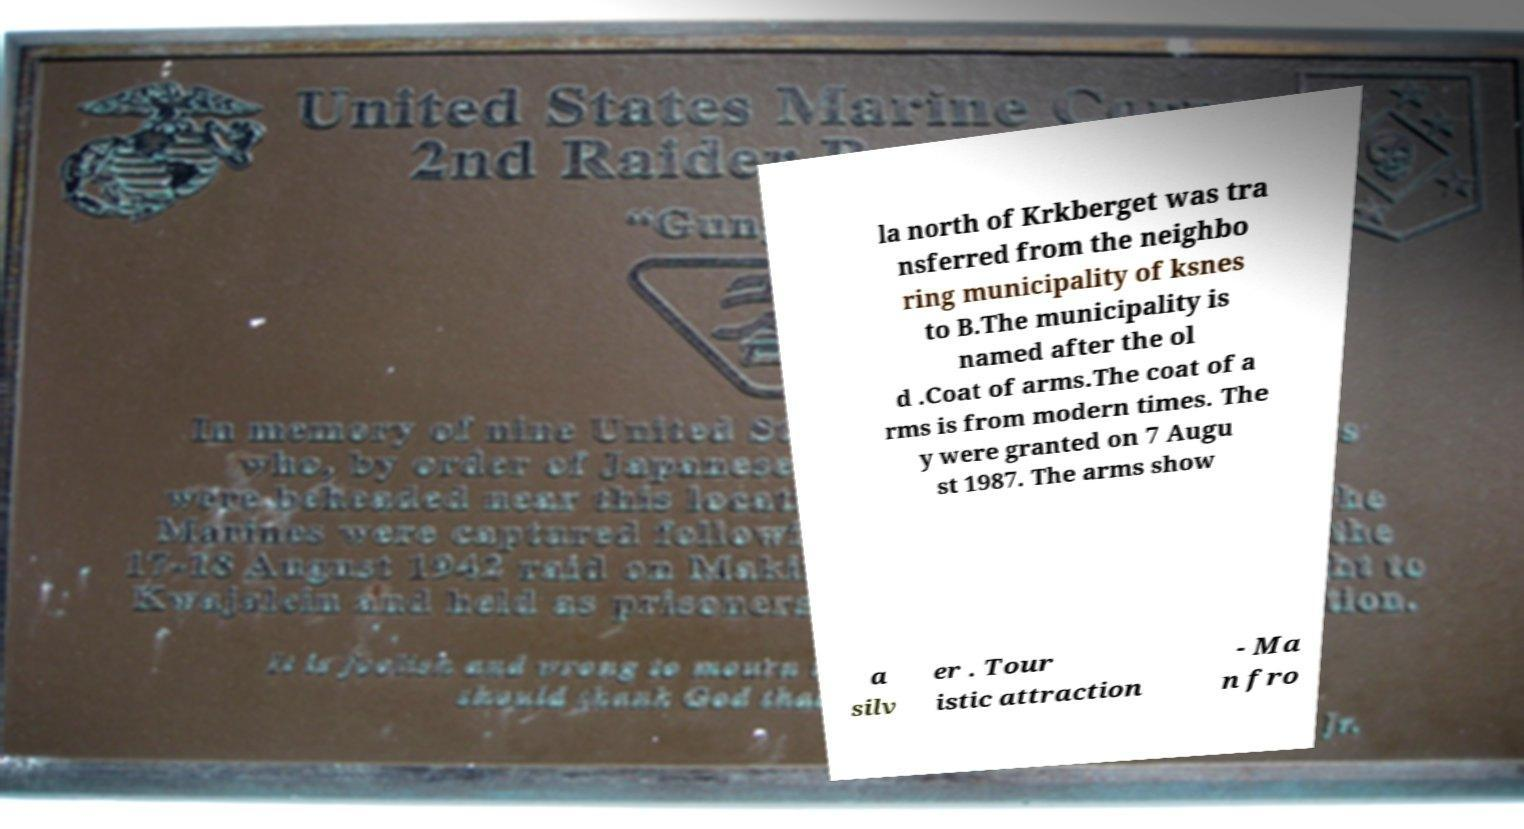For documentation purposes, I need the text within this image transcribed. Could you provide that? la north of Krkberget was tra nsferred from the neighbo ring municipality of ksnes to B.The municipality is named after the ol d .Coat of arms.The coat of a rms is from modern times. The y were granted on 7 Augu st 1987. The arms show a silv er . Tour istic attraction - Ma n fro 